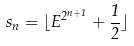Convert formula to latex. <formula><loc_0><loc_0><loc_500><loc_500>s _ { n } = \lfloor E ^ { 2 ^ { n + 1 } } + \frac { 1 } { 2 } \rfloor</formula> 